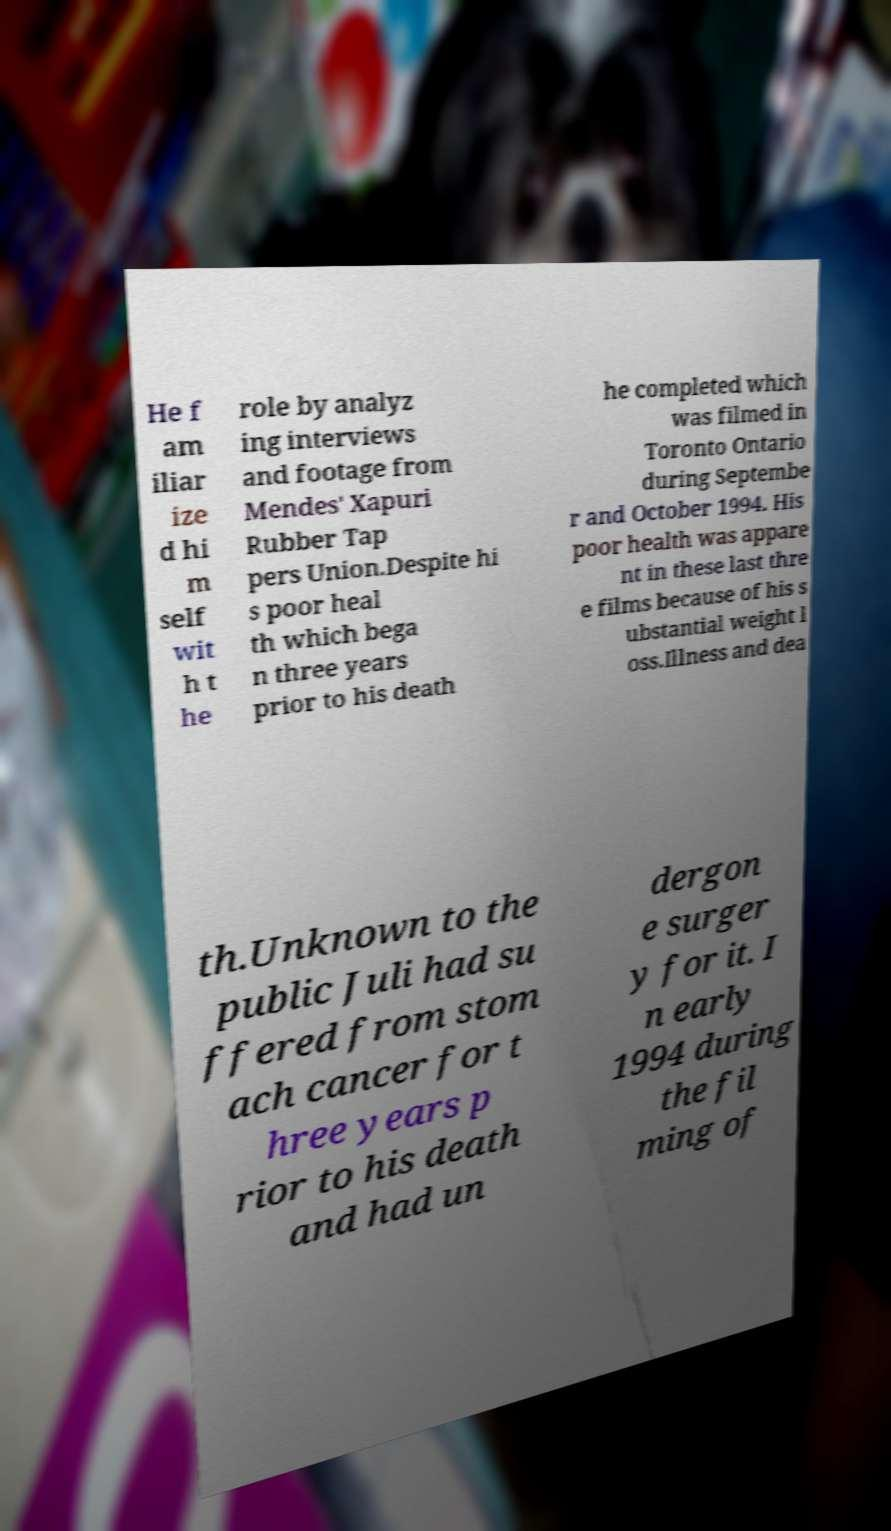Please read and relay the text visible in this image. What does it say? He f am iliar ize d hi m self wit h t he role by analyz ing interviews and footage from Mendes' Xapuri Rubber Tap pers Union.Despite hi s poor heal th which bega n three years prior to his death he completed which was filmed in Toronto Ontario during Septembe r and October 1994. His poor health was appare nt in these last thre e films because of his s ubstantial weight l oss.Illness and dea th.Unknown to the public Juli had su ffered from stom ach cancer for t hree years p rior to his death and had un dergon e surger y for it. I n early 1994 during the fil ming of 